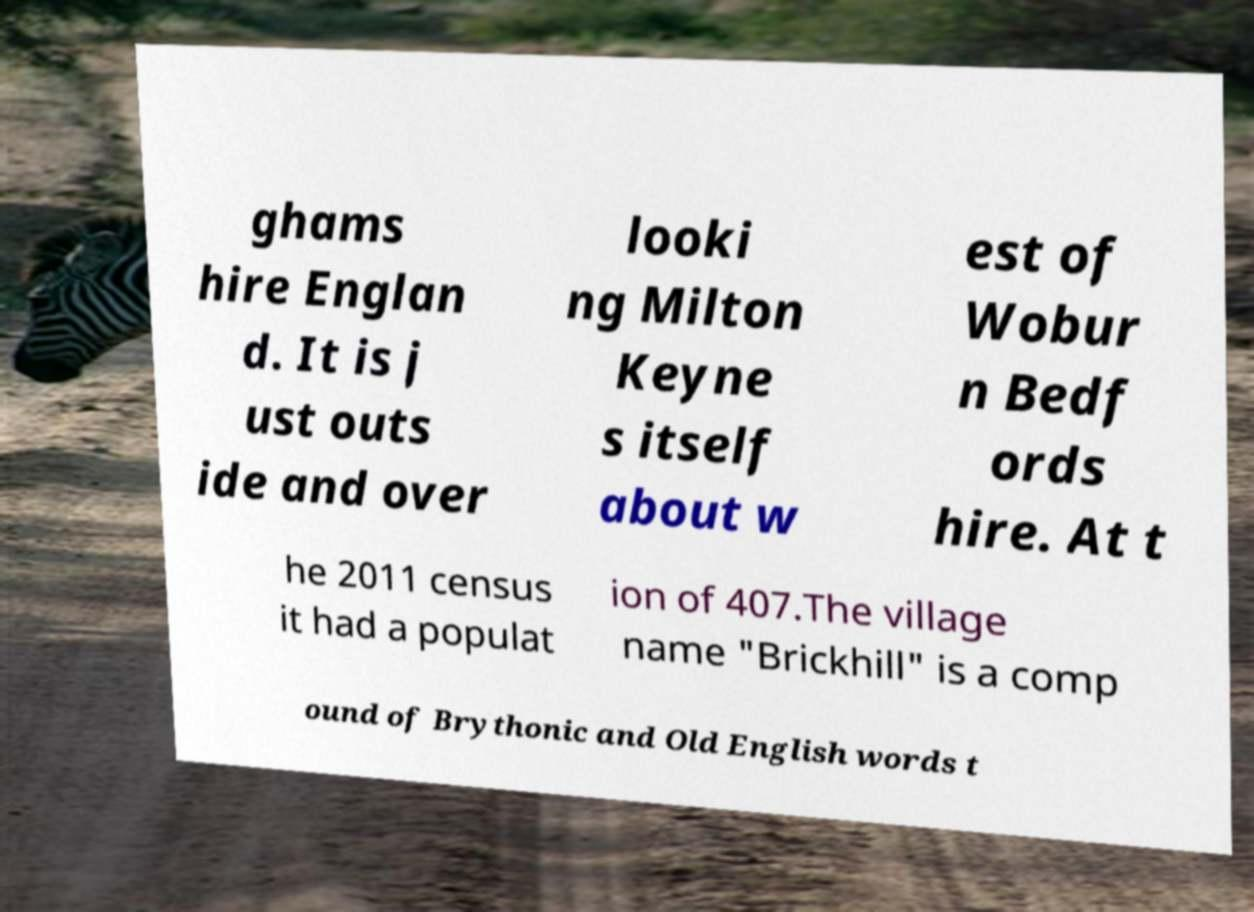I need the written content from this picture converted into text. Can you do that? ghams hire Englan d. It is j ust outs ide and over looki ng Milton Keyne s itself about w est of Wobur n Bedf ords hire. At t he 2011 census it had a populat ion of 407.The village name "Brickhill" is a comp ound of Brythonic and Old English words t 